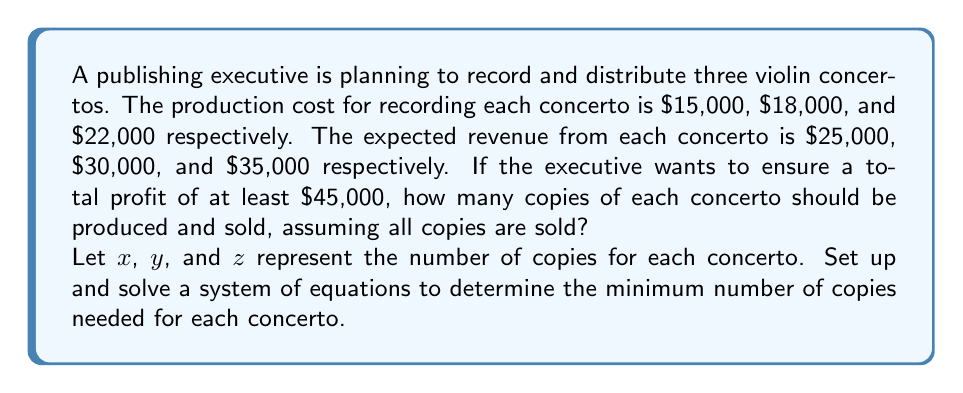Can you solve this math problem? To solve this problem, we need to set up a system of equations based on the given information:

1) Let's define our variables:
   $x$ = number of copies of the first concerto
   $y$ = number of copies of the second concerto
   $z$ = number of copies of the third concerto

2) We can set up an equation for the total profit:
   $$(25000x - 15000x) + (30000y - 18000y) + (35000z - 22000z) \geq 45000$$

3) Simplifying this equation:
   $$10000x + 12000y + 13000z \geq 45000$$

4) We want to minimize the total number of copies, so we can set up an objective function:
   $$\text{Minimize: } x + y + z$$

5) To solve this linear programming problem, we can use the simplex method or a graphical method. However, since we're looking for integer solutions, we can use a simple approach:

   Let's start with the smallest possible values for $x$, $y$, and $z$:

   $$10000(1) + 12000(1) + 13000(1) = 35000 < 45000$$

   This is not enough, so let's increase $z$ (which contributes the most to the profit):

   $$10000(1) + 12000(1) + 13000(2) = 48000 \geq 45000$$

6) Therefore, the minimum solution is:
   $x = 1$, $y = 1$, $z = 2$
Answer: The publishing executive should produce and sell at least 1 copy of the first concerto, 1 copy of the second concerto, and 2 copies of the third concerto to ensure a total profit of at least $45,000. 